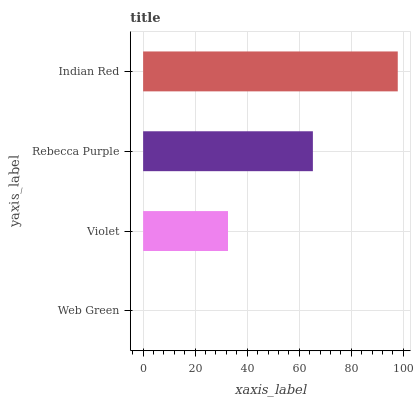Is Web Green the minimum?
Answer yes or no. Yes. Is Indian Red the maximum?
Answer yes or no. Yes. Is Violet the minimum?
Answer yes or no. No. Is Violet the maximum?
Answer yes or no. No. Is Violet greater than Web Green?
Answer yes or no. Yes. Is Web Green less than Violet?
Answer yes or no. Yes. Is Web Green greater than Violet?
Answer yes or no. No. Is Violet less than Web Green?
Answer yes or no. No. Is Rebecca Purple the high median?
Answer yes or no. Yes. Is Violet the low median?
Answer yes or no. Yes. Is Indian Red the high median?
Answer yes or no. No. Is Indian Red the low median?
Answer yes or no. No. 